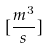Convert formula to latex. <formula><loc_0><loc_0><loc_500><loc_500>[ \frac { m ^ { 3 } } { s } ]</formula> 